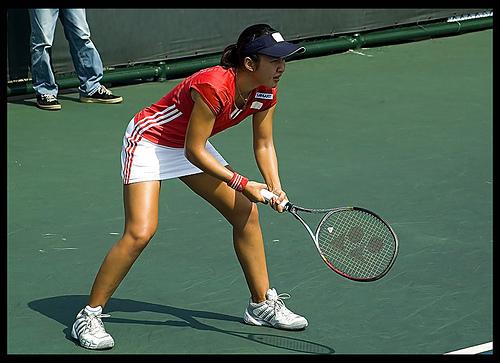What color is the women's shirt?
Give a very brief answer. Red. Is there a tennis racket?
Concise answer only. Yes. Is the girls right arm in an awkward position?
Answer briefly. No. What brand are the shoes?
Give a very brief answer. Adidas. What color is the persons skirt?
Write a very short answer. White. Is this an Olympic tennis match?
Write a very short answer. No. 